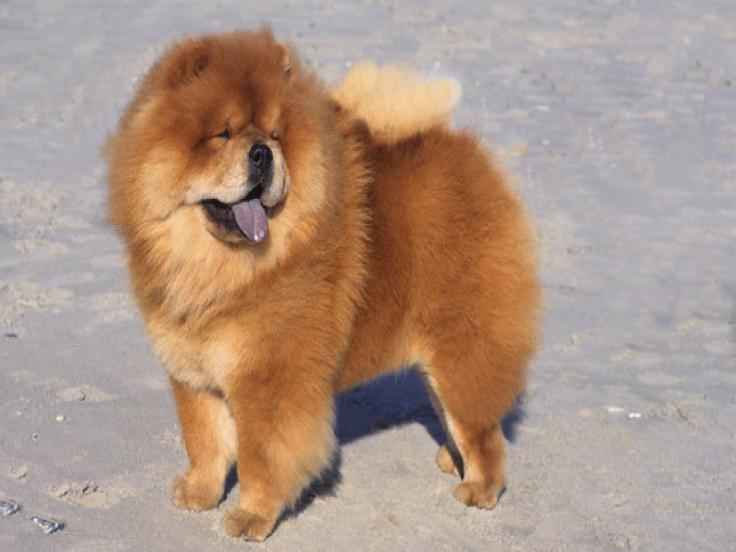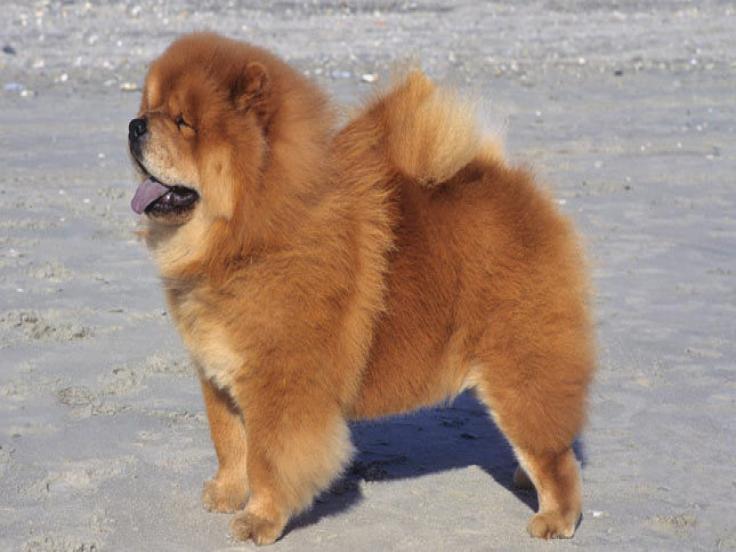The first image is the image on the left, the second image is the image on the right. Evaluate the accuracy of this statement regarding the images: "A human is holding at least one Chow Chow puppy in their arms.". Is it true? Answer yes or no. No. The first image is the image on the left, the second image is the image on the right. Considering the images on both sides, is "There is a human handling at least one dog in the right image." valid? Answer yes or no. No. 